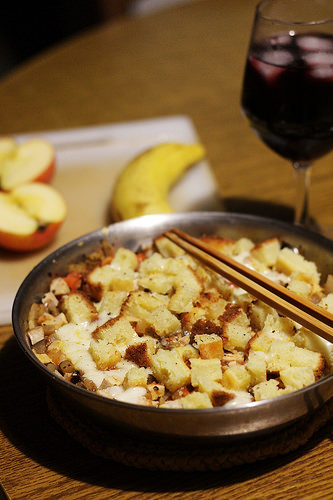<image>
Can you confirm if the banana is behind the food? Yes. From this viewpoint, the banana is positioned behind the food, with the food partially or fully occluding the banana. 